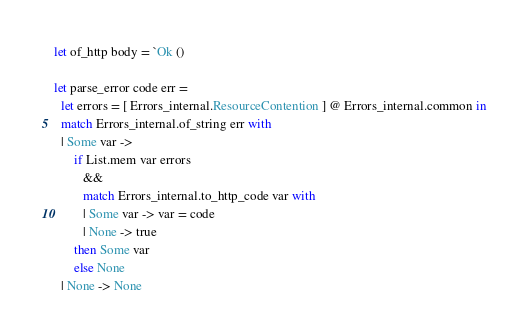<code> <loc_0><loc_0><loc_500><loc_500><_OCaml_>let of_http body = `Ok ()

let parse_error code err =
  let errors = [ Errors_internal.ResourceContention ] @ Errors_internal.common in
  match Errors_internal.of_string err with
  | Some var ->
      if List.mem var errors
         &&
         match Errors_internal.to_http_code var with
         | Some var -> var = code
         | None -> true
      then Some var
      else None
  | None -> None
</code> 